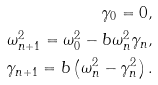Convert formula to latex. <formula><loc_0><loc_0><loc_500><loc_500>\gamma _ { 0 } = 0 , \\ \omega _ { n + 1 } ^ { 2 } = \omega _ { 0 } ^ { 2 } - b \omega _ { n } ^ { 2 } \gamma _ { n } , \\ \gamma _ { n + 1 } = b \left ( \omega _ { n } ^ { 2 } - \gamma _ { n } ^ { 2 } \right ) .</formula> 